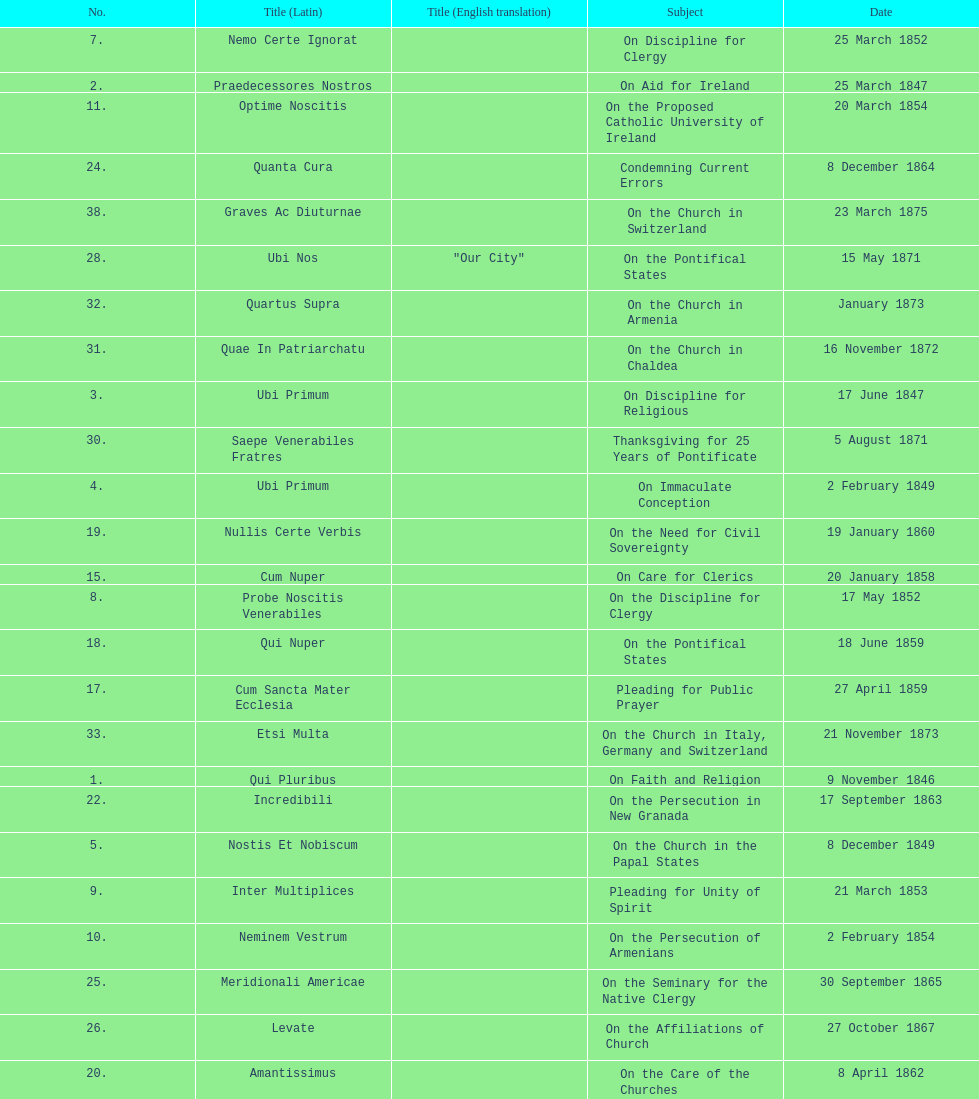What is the previous subject after on the effects of the jubilee? On the Church in the Papal States. 